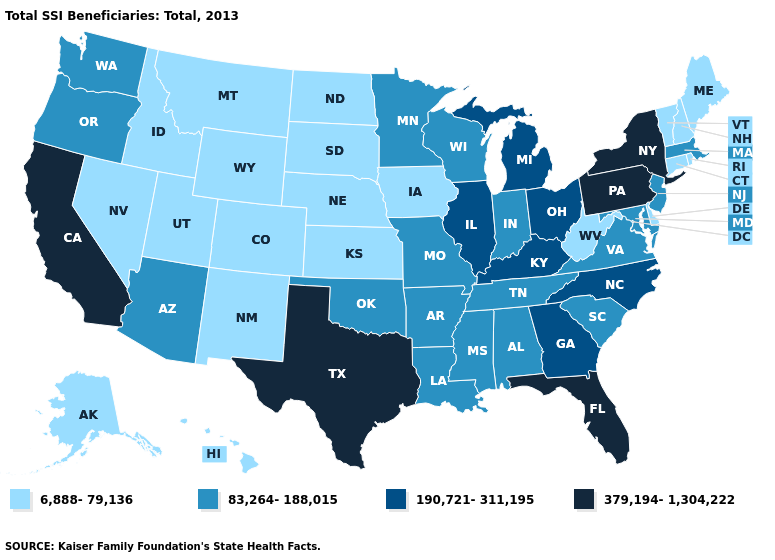What is the value of Pennsylvania?
Write a very short answer. 379,194-1,304,222. Does the first symbol in the legend represent the smallest category?
Write a very short answer. Yes. Does Alaska have the highest value in the USA?
Be succinct. No. Among the states that border Delaware , does New Jersey have the highest value?
Answer briefly. No. Does Arizona have the same value as Iowa?
Answer briefly. No. Which states have the lowest value in the USA?
Concise answer only. Alaska, Colorado, Connecticut, Delaware, Hawaii, Idaho, Iowa, Kansas, Maine, Montana, Nebraska, Nevada, New Hampshire, New Mexico, North Dakota, Rhode Island, South Dakota, Utah, Vermont, West Virginia, Wyoming. Name the states that have a value in the range 6,888-79,136?
Answer briefly. Alaska, Colorado, Connecticut, Delaware, Hawaii, Idaho, Iowa, Kansas, Maine, Montana, Nebraska, Nevada, New Hampshire, New Mexico, North Dakota, Rhode Island, South Dakota, Utah, Vermont, West Virginia, Wyoming. Does Florida have the highest value in the South?
Quick response, please. Yes. Name the states that have a value in the range 83,264-188,015?
Write a very short answer. Alabama, Arizona, Arkansas, Indiana, Louisiana, Maryland, Massachusetts, Minnesota, Mississippi, Missouri, New Jersey, Oklahoma, Oregon, South Carolina, Tennessee, Virginia, Washington, Wisconsin. What is the lowest value in the MidWest?
Quick response, please. 6,888-79,136. Among the states that border Maine , which have the lowest value?
Concise answer only. New Hampshire. What is the lowest value in states that border South Carolina?
Concise answer only. 190,721-311,195. Name the states that have a value in the range 83,264-188,015?
Concise answer only. Alabama, Arizona, Arkansas, Indiana, Louisiana, Maryland, Massachusetts, Minnesota, Mississippi, Missouri, New Jersey, Oklahoma, Oregon, South Carolina, Tennessee, Virginia, Washington, Wisconsin. Name the states that have a value in the range 6,888-79,136?
Short answer required. Alaska, Colorado, Connecticut, Delaware, Hawaii, Idaho, Iowa, Kansas, Maine, Montana, Nebraska, Nevada, New Hampshire, New Mexico, North Dakota, Rhode Island, South Dakota, Utah, Vermont, West Virginia, Wyoming. 